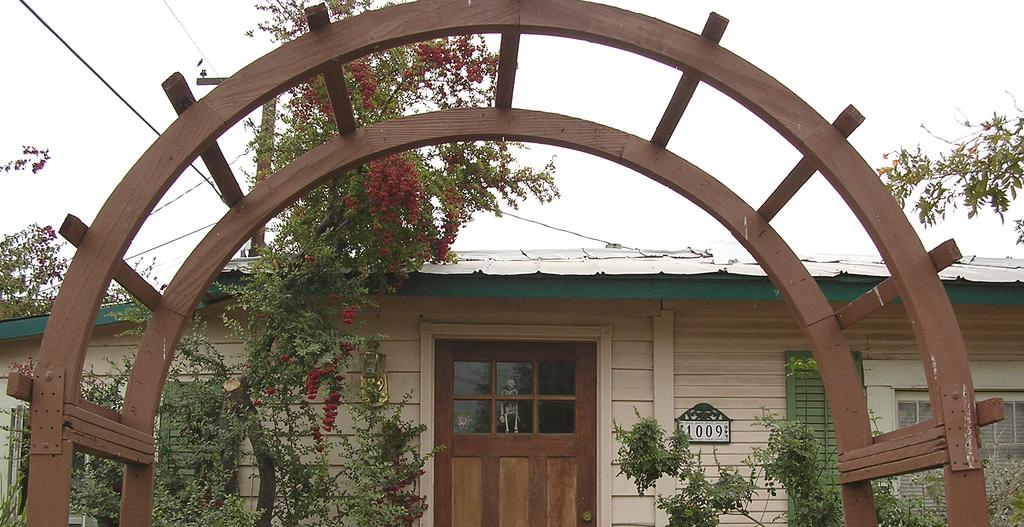What type of structure is in the image? There is a house in the image. What features can be seen on the house? The house has a door and a window. What is located in front of the house? There is a wooden arch in front of the house. What can be seen in front of the wooden arch? Trees are visible in front of the house. What is visible in the background of the image? The sky is visible in the background of the image. How many frogs are sitting on the quartz in the image? There are no frogs or quartz present in the image. 